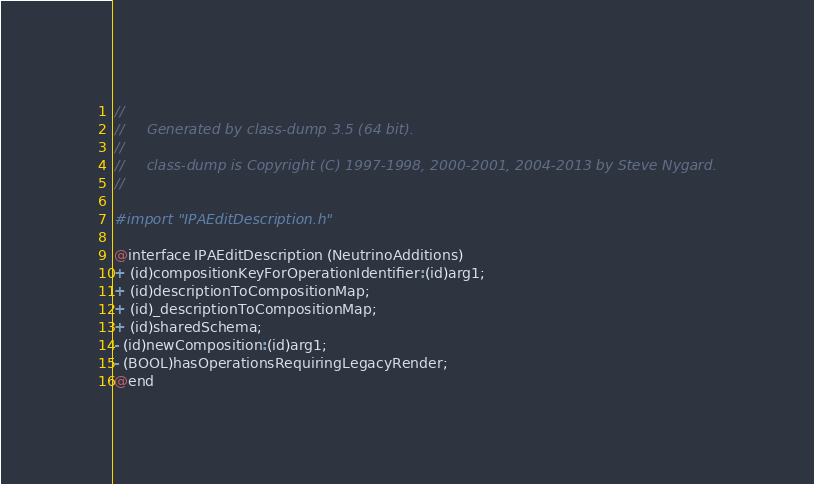<code> <loc_0><loc_0><loc_500><loc_500><_C_>//
//     Generated by class-dump 3.5 (64 bit).
//
//     class-dump is Copyright (C) 1997-1998, 2000-2001, 2004-2013 by Steve Nygard.
//

#import "IPAEditDescription.h"

@interface IPAEditDescription (NeutrinoAdditions)
+ (id)compositionKeyForOperationIdentifier:(id)arg1;
+ (id)descriptionToCompositionMap;
+ (id)_descriptionToCompositionMap;
+ (id)sharedSchema;
- (id)newComposition:(id)arg1;
- (BOOL)hasOperationsRequiringLegacyRender;
@end

</code> 